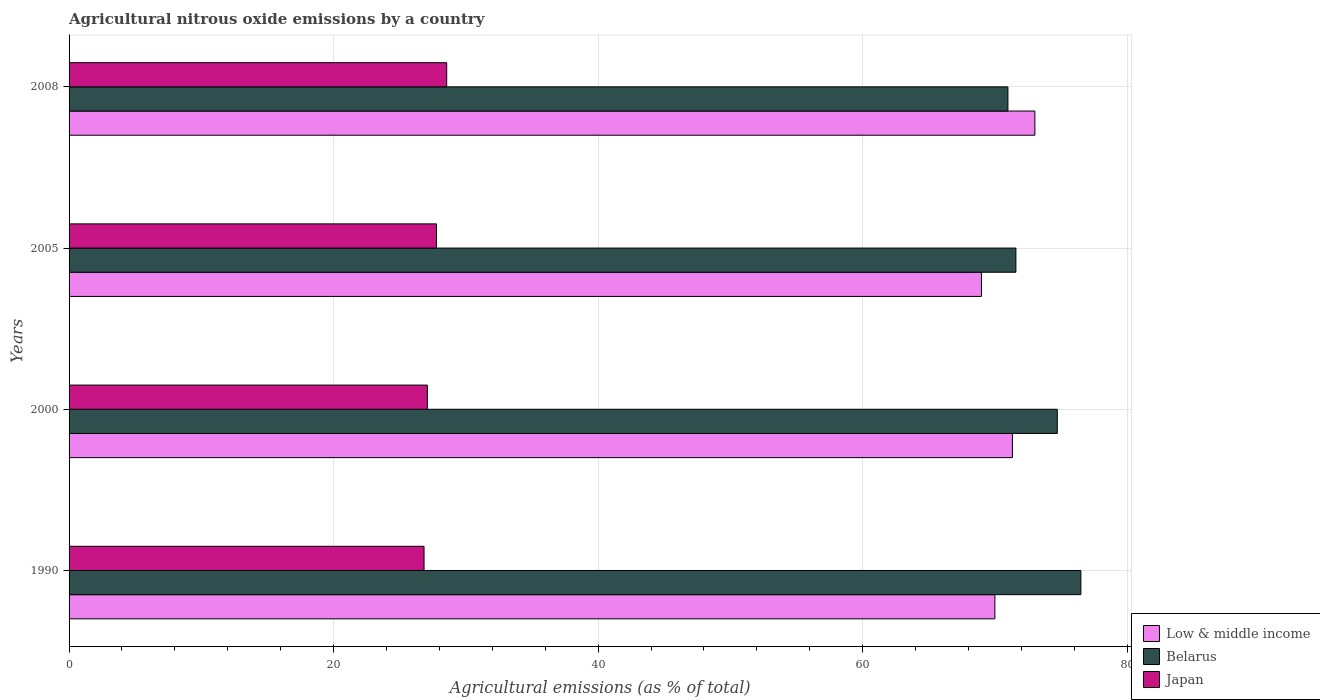How many different coloured bars are there?
Your answer should be compact. 3. Are the number of bars per tick equal to the number of legend labels?
Offer a terse response. Yes. How many bars are there on the 4th tick from the bottom?
Keep it short and to the point. 3. What is the label of the 1st group of bars from the top?
Offer a very short reply. 2008. In how many cases, is the number of bars for a given year not equal to the number of legend labels?
Your answer should be compact. 0. What is the amount of agricultural nitrous oxide emitted in Japan in 1990?
Your answer should be very brief. 26.84. Across all years, what is the maximum amount of agricultural nitrous oxide emitted in Japan?
Offer a terse response. 28.55. Across all years, what is the minimum amount of agricultural nitrous oxide emitted in Belarus?
Offer a very short reply. 70.98. In which year was the amount of agricultural nitrous oxide emitted in Low & middle income minimum?
Ensure brevity in your answer.  2005. What is the total amount of agricultural nitrous oxide emitted in Low & middle income in the graph?
Offer a terse response. 283.33. What is the difference between the amount of agricultural nitrous oxide emitted in Japan in 2000 and that in 2008?
Offer a terse response. -1.46. What is the difference between the amount of agricultural nitrous oxide emitted in Japan in 1990 and the amount of agricultural nitrous oxide emitted in Low & middle income in 2008?
Make the answer very short. -46.18. What is the average amount of agricultural nitrous oxide emitted in Low & middle income per year?
Your response must be concise. 70.83. In the year 2000, what is the difference between the amount of agricultural nitrous oxide emitted in Low & middle income and amount of agricultural nitrous oxide emitted in Belarus?
Provide a succinct answer. -3.39. What is the ratio of the amount of agricultural nitrous oxide emitted in Low & middle income in 1990 to that in 2005?
Keep it short and to the point. 1.01. Is the amount of agricultural nitrous oxide emitted in Belarus in 1990 less than that in 2005?
Offer a terse response. No. What is the difference between the highest and the second highest amount of agricultural nitrous oxide emitted in Low & middle income?
Provide a succinct answer. 1.7. What is the difference between the highest and the lowest amount of agricultural nitrous oxide emitted in Low & middle income?
Make the answer very short. 4.04. In how many years, is the amount of agricultural nitrous oxide emitted in Low & middle income greater than the average amount of agricultural nitrous oxide emitted in Low & middle income taken over all years?
Give a very brief answer. 2. What does the 2nd bar from the top in 1990 represents?
Ensure brevity in your answer.  Belarus. What does the 1st bar from the bottom in 2005 represents?
Keep it short and to the point. Low & middle income. Are all the bars in the graph horizontal?
Give a very brief answer. Yes. What is the difference between two consecutive major ticks on the X-axis?
Give a very brief answer. 20. Does the graph contain any zero values?
Give a very brief answer. No. Does the graph contain grids?
Provide a short and direct response. Yes. Where does the legend appear in the graph?
Your response must be concise. Bottom right. How many legend labels are there?
Offer a terse response. 3. How are the legend labels stacked?
Make the answer very short. Vertical. What is the title of the graph?
Provide a short and direct response. Agricultural nitrous oxide emissions by a country. Does "Rwanda" appear as one of the legend labels in the graph?
Your answer should be compact. No. What is the label or title of the X-axis?
Provide a succinct answer. Agricultural emissions (as % of total). What is the Agricultural emissions (as % of total) in Low & middle income in 1990?
Your answer should be very brief. 70. What is the Agricultural emissions (as % of total) in Belarus in 1990?
Your answer should be compact. 76.5. What is the Agricultural emissions (as % of total) of Japan in 1990?
Provide a succinct answer. 26.84. What is the Agricultural emissions (as % of total) of Low & middle income in 2000?
Provide a short and direct response. 71.32. What is the Agricultural emissions (as % of total) in Belarus in 2000?
Make the answer very short. 74.72. What is the Agricultural emissions (as % of total) in Japan in 2000?
Your response must be concise. 27.09. What is the Agricultural emissions (as % of total) in Low & middle income in 2005?
Offer a terse response. 68.98. What is the Agricultural emissions (as % of total) in Belarus in 2005?
Your answer should be very brief. 71.59. What is the Agricultural emissions (as % of total) of Japan in 2005?
Keep it short and to the point. 27.78. What is the Agricultural emissions (as % of total) in Low & middle income in 2008?
Ensure brevity in your answer.  73.02. What is the Agricultural emissions (as % of total) of Belarus in 2008?
Offer a very short reply. 70.98. What is the Agricultural emissions (as % of total) in Japan in 2008?
Provide a short and direct response. 28.55. Across all years, what is the maximum Agricultural emissions (as % of total) of Low & middle income?
Give a very brief answer. 73.02. Across all years, what is the maximum Agricultural emissions (as % of total) in Belarus?
Your response must be concise. 76.5. Across all years, what is the maximum Agricultural emissions (as % of total) in Japan?
Offer a terse response. 28.55. Across all years, what is the minimum Agricultural emissions (as % of total) in Low & middle income?
Offer a terse response. 68.98. Across all years, what is the minimum Agricultural emissions (as % of total) in Belarus?
Give a very brief answer. 70.98. Across all years, what is the minimum Agricultural emissions (as % of total) in Japan?
Your answer should be compact. 26.84. What is the total Agricultural emissions (as % of total) of Low & middle income in the graph?
Offer a very short reply. 283.33. What is the total Agricultural emissions (as % of total) of Belarus in the graph?
Provide a short and direct response. 293.79. What is the total Agricultural emissions (as % of total) of Japan in the graph?
Keep it short and to the point. 110.26. What is the difference between the Agricultural emissions (as % of total) in Low & middle income in 1990 and that in 2000?
Your response must be concise. -1.33. What is the difference between the Agricultural emissions (as % of total) in Belarus in 1990 and that in 2000?
Make the answer very short. 1.78. What is the difference between the Agricultural emissions (as % of total) of Japan in 1990 and that in 2000?
Your response must be concise. -0.25. What is the difference between the Agricultural emissions (as % of total) in Low & middle income in 1990 and that in 2005?
Your answer should be very brief. 1.02. What is the difference between the Agricultural emissions (as % of total) in Belarus in 1990 and that in 2005?
Provide a succinct answer. 4.91. What is the difference between the Agricultural emissions (as % of total) of Japan in 1990 and that in 2005?
Make the answer very short. -0.94. What is the difference between the Agricultural emissions (as % of total) of Low & middle income in 1990 and that in 2008?
Provide a short and direct response. -3.03. What is the difference between the Agricultural emissions (as % of total) in Belarus in 1990 and that in 2008?
Make the answer very short. 5.51. What is the difference between the Agricultural emissions (as % of total) in Japan in 1990 and that in 2008?
Offer a very short reply. -1.71. What is the difference between the Agricultural emissions (as % of total) in Low & middle income in 2000 and that in 2005?
Offer a very short reply. 2.34. What is the difference between the Agricultural emissions (as % of total) in Belarus in 2000 and that in 2005?
Make the answer very short. 3.13. What is the difference between the Agricultural emissions (as % of total) in Japan in 2000 and that in 2005?
Offer a very short reply. -0.69. What is the difference between the Agricultural emissions (as % of total) in Low & middle income in 2000 and that in 2008?
Offer a terse response. -1.7. What is the difference between the Agricultural emissions (as % of total) of Belarus in 2000 and that in 2008?
Your answer should be very brief. 3.73. What is the difference between the Agricultural emissions (as % of total) in Japan in 2000 and that in 2008?
Your answer should be compact. -1.46. What is the difference between the Agricultural emissions (as % of total) of Low & middle income in 2005 and that in 2008?
Provide a short and direct response. -4.04. What is the difference between the Agricultural emissions (as % of total) in Belarus in 2005 and that in 2008?
Provide a short and direct response. 0.6. What is the difference between the Agricultural emissions (as % of total) of Japan in 2005 and that in 2008?
Your answer should be very brief. -0.77. What is the difference between the Agricultural emissions (as % of total) of Low & middle income in 1990 and the Agricultural emissions (as % of total) of Belarus in 2000?
Provide a short and direct response. -4.72. What is the difference between the Agricultural emissions (as % of total) in Low & middle income in 1990 and the Agricultural emissions (as % of total) in Japan in 2000?
Your answer should be compact. 42.91. What is the difference between the Agricultural emissions (as % of total) of Belarus in 1990 and the Agricultural emissions (as % of total) of Japan in 2000?
Your answer should be compact. 49.41. What is the difference between the Agricultural emissions (as % of total) of Low & middle income in 1990 and the Agricultural emissions (as % of total) of Belarus in 2005?
Your response must be concise. -1.59. What is the difference between the Agricultural emissions (as % of total) of Low & middle income in 1990 and the Agricultural emissions (as % of total) of Japan in 2005?
Give a very brief answer. 42.22. What is the difference between the Agricultural emissions (as % of total) of Belarus in 1990 and the Agricultural emissions (as % of total) of Japan in 2005?
Provide a succinct answer. 48.72. What is the difference between the Agricultural emissions (as % of total) in Low & middle income in 1990 and the Agricultural emissions (as % of total) in Belarus in 2008?
Ensure brevity in your answer.  -0.99. What is the difference between the Agricultural emissions (as % of total) of Low & middle income in 1990 and the Agricultural emissions (as % of total) of Japan in 2008?
Offer a very short reply. 41.45. What is the difference between the Agricultural emissions (as % of total) in Belarus in 1990 and the Agricultural emissions (as % of total) in Japan in 2008?
Make the answer very short. 47.95. What is the difference between the Agricultural emissions (as % of total) in Low & middle income in 2000 and the Agricultural emissions (as % of total) in Belarus in 2005?
Offer a terse response. -0.26. What is the difference between the Agricultural emissions (as % of total) in Low & middle income in 2000 and the Agricultural emissions (as % of total) in Japan in 2005?
Keep it short and to the point. 43.55. What is the difference between the Agricultural emissions (as % of total) in Belarus in 2000 and the Agricultural emissions (as % of total) in Japan in 2005?
Keep it short and to the point. 46.94. What is the difference between the Agricultural emissions (as % of total) of Low & middle income in 2000 and the Agricultural emissions (as % of total) of Belarus in 2008?
Offer a terse response. 0.34. What is the difference between the Agricultural emissions (as % of total) in Low & middle income in 2000 and the Agricultural emissions (as % of total) in Japan in 2008?
Your answer should be very brief. 42.77. What is the difference between the Agricultural emissions (as % of total) in Belarus in 2000 and the Agricultural emissions (as % of total) in Japan in 2008?
Give a very brief answer. 46.16. What is the difference between the Agricultural emissions (as % of total) in Low & middle income in 2005 and the Agricultural emissions (as % of total) in Belarus in 2008?
Offer a very short reply. -2. What is the difference between the Agricultural emissions (as % of total) in Low & middle income in 2005 and the Agricultural emissions (as % of total) in Japan in 2008?
Ensure brevity in your answer.  40.43. What is the difference between the Agricultural emissions (as % of total) in Belarus in 2005 and the Agricultural emissions (as % of total) in Japan in 2008?
Keep it short and to the point. 43.04. What is the average Agricultural emissions (as % of total) in Low & middle income per year?
Your answer should be very brief. 70.83. What is the average Agricultural emissions (as % of total) of Belarus per year?
Offer a terse response. 73.45. What is the average Agricultural emissions (as % of total) in Japan per year?
Ensure brevity in your answer.  27.56. In the year 1990, what is the difference between the Agricultural emissions (as % of total) of Low & middle income and Agricultural emissions (as % of total) of Belarus?
Give a very brief answer. -6.5. In the year 1990, what is the difference between the Agricultural emissions (as % of total) in Low & middle income and Agricultural emissions (as % of total) in Japan?
Offer a terse response. 43.16. In the year 1990, what is the difference between the Agricultural emissions (as % of total) in Belarus and Agricultural emissions (as % of total) in Japan?
Make the answer very short. 49.66. In the year 2000, what is the difference between the Agricultural emissions (as % of total) in Low & middle income and Agricultural emissions (as % of total) in Belarus?
Offer a terse response. -3.39. In the year 2000, what is the difference between the Agricultural emissions (as % of total) in Low & middle income and Agricultural emissions (as % of total) in Japan?
Your response must be concise. 44.24. In the year 2000, what is the difference between the Agricultural emissions (as % of total) in Belarus and Agricultural emissions (as % of total) in Japan?
Your answer should be compact. 47.63. In the year 2005, what is the difference between the Agricultural emissions (as % of total) in Low & middle income and Agricultural emissions (as % of total) in Belarus?
Your response must be concise. -2.61. In the year 2005, what is the difference between the Agricultural emissions (as % of total) in Low & middle income and Agricultural emissions (as % of total) in Japan?
Offer a very short reply. 41.2. In the year 2005, what is the difference between the Agricultural emissions (as % of total) in Belarus and Agricultural emissions (as % of total) in Japan?
Offer a very short reply. 43.81. In the year 2008, what is the difference between the Agricultural emissions (as % of total) in Low & middle income and Agricultural emissions (as % of total) in Belarus?
Offer a terse response. 2.04. In the year 2008, what is the difference between the Agricultural emissions (as % of total) in Low & middle income and Agricultural emissions (as % of total) in Japan?
Ensure brevity in your answer.  44.47. In the year 2008, what is the difference between the Agricultural emissions (as % of total) of Belarus and Agricultural emissions (as % of total) of Japan?
Provide a short and direct response. 42.43. What is the ratio of the Agricultural emissions (as % of total) of Low & middle income in 1990 to that in 2000?
Your answer should be very brief. 0.98. What is the ratio of the Agricultural emissions (as % of total) of Belarus in 1990 to that in 2000?
Offer a very short reply. 1.02. What is the ratio of the Agricultural emissions (as % of total) of Low & middle income in 1990 to that in 2005?
Offer a terse response. 1.01. What is the ratio of the Agricultural emissions (as % of total) of Belarus in 1990 to that in 2005?
Your response must be concise. 1.07. What is the ratio of the Agricultural emissions (as % of total) in Japan in 1990 to that in 2005?
Provide a succinct answer. 0.97. What is the ratio of the Agricultural emissions (as % of total) of Low & middle income in 1990 to that in 2008?
Provide a succinct answer. 0.96. What is the ratio of the Agricultural emissions (as % of total) of Belarus in 1990 to that in 2008?
Keep it short and to the point. 1.08. What is the ratio of the Agricultural emissions (as % of total) of Japan in 1990 to that in 2008?
Your response must be concise. 0.94. What is the ratio of the Agricultural emissions (as % of total) in Low & middle income in 2000 to that in 2005?
Provide a short and direct response. 1.03. What is the ratio of the Agricultural emissions (as % of total) in Belarus in 2000 to that in 2005?
Your response must be concise. 1.04. What is the ratio of the Agricultural emissions (as % of total) in Japan in 2000 to that in 2005?
Your answer should be very brief. 0.98. What is the ratio of the Agricultural emissions (as % of total) in Low & middle income in 2000 to that in 2008?
Provide a short and direct response. 0.98. What is the ratio of the Agricultural emissions (as % of total) of Belarus in 2000 to that in 2008?
Your response must be concise. 1.05. What is the ratio of the Agricultural emissions (as % of total) in Japan in 2000 to that in 2008?
Offer a terse response. 0.95. What is the ratio of the Agricultural emissions (as % of total) in Low & middle income in 2005 to that in 2008?
Offer a terse response. 0.94. What is the ratio of the Agricultural emissions (as % of total) in Belarus in 2005 to that in 2008?
Keep it short and to the point. 1.01. What is the ratio of the Agricultural emissions (as % of total) of Japan in 2005 to that in 2008?
Your answer should be compact. 0.97. What is the difference between the highest and the second highest Agricultural emissions (as % of total) of Low & middle income?
Provide a short and direct response. 1.7. What is the difference between the highest and the second highest Agricultural emissions (as % of total) of Belarus?
Offer a very short reply. 1.78. What is the difference between the highest and the second highest Agricultural emissions (as % of total) of Japan?
Your answer should be compact. 0.77. What is the difference between the highest and the lowest Agricultural emissions (as % of total) in Low & middle income?
Your response must be concise. 4.04. What is the difference between the highest and the lowest Agricultural emissions (as % of total) of Belarus?
Keep it short and to the point. 5.51. What is the difference between the highest and the lowest Agricultural emissions (as % of total) of Japan?
Keep it short and to the point. 1.71. 